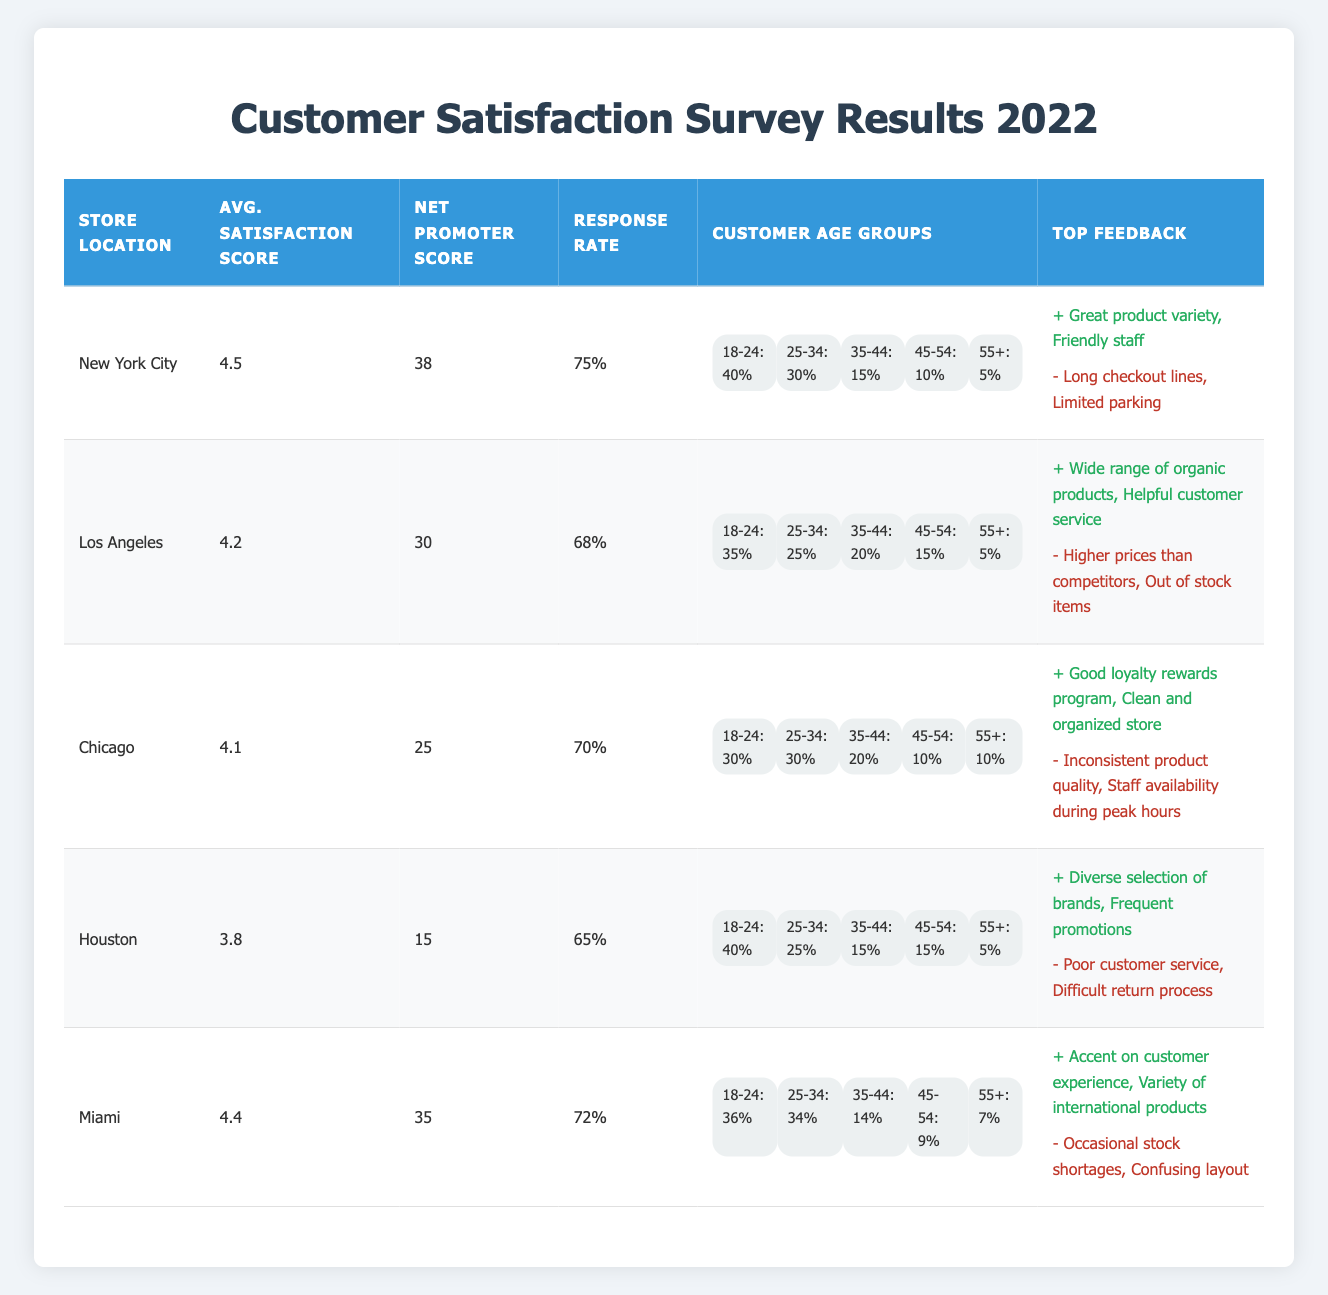What is the average satisfaction score across all store locations? To find the average satisfaction score, we need to add up the average satisfaction scores from all locations and then divide by the number of locations. The scores are 4.5 (NYC), 4.2 (LA), 4.1 (Chicago), 3.8 (Houston), and 4.4 (Miami). The sum is 4.5 + 4.2 + 4.1 + 3.8 + 4.4 = 20. The number of locations is 5, so the average is 20 / 5 = 4.0.
Answer: 4.0 Which store has the highest net promoter score? Comparing the net promoter scores from each store, New York City has a score of 38, Los Angeles has 30, Chicago has 25, Houston has 15, and Miami has 35. The highest score is 38 from New York City.
Answer: New York City Is the response rate for Houston higher than that for Chicago? Houston has a response rate of 65%, while Chicago's response rate is 70%. Since 65% is less than 70%, the response rate for Houston is not higher than that for Chicago.
Answer: No What percentage of customers aged 18-24 responded in the Los Angeles store? In the Los Angeles store, the percentage of customers aged 18-24 is 35%. This is directly stated in the customer age group for Los Angeles within the table.
Answer: 35% What is the difference in average satisfaction scores between the highest and lowest rated stores? The store with the highest average satisfaction score is New York City at 4.5, and the lowest is Houston at 3.8. To find the difference, we subtract the lowest from the highest: 4.5 - 3.8 = 0.7.
Answer: 0.7 Does Miami have a higher average satisfaction score than Los Angeles? Miami has an average satisfaction score of 4.4, while Los Angeles has 4.2. Since 4.4 is greater than 4.2, Miami does have a higher score.
Answer: Yes What is the total percentage of respondents aged 35-44 and 45-54 across all locations? From the age group data, the percentages are as follows: New York City has 15% (35-44) and 10% (45-54), Los Angeles has 20% (35-44) and 15% (45-54), Chicago has 20% (35-44) and 10% (45-54), Houston has 15% (35-44) and 15% (45-54), and Miami has 14% (35-44) and 9% (45-54). Adding these, we calculate (15 + 20 + 20 + 15 + 14) + (10 + 15 + 10 + 15 + 9) = 84%.
Answer: 84% How many stores received a net promoter score of 30 or above? The stores with a net promoter score of 30 or above are New York City (38), Los Angeles (30), and Miami (35). This totals to three stores: New York City, Los Angeles, and Miami.
Answer: 3 